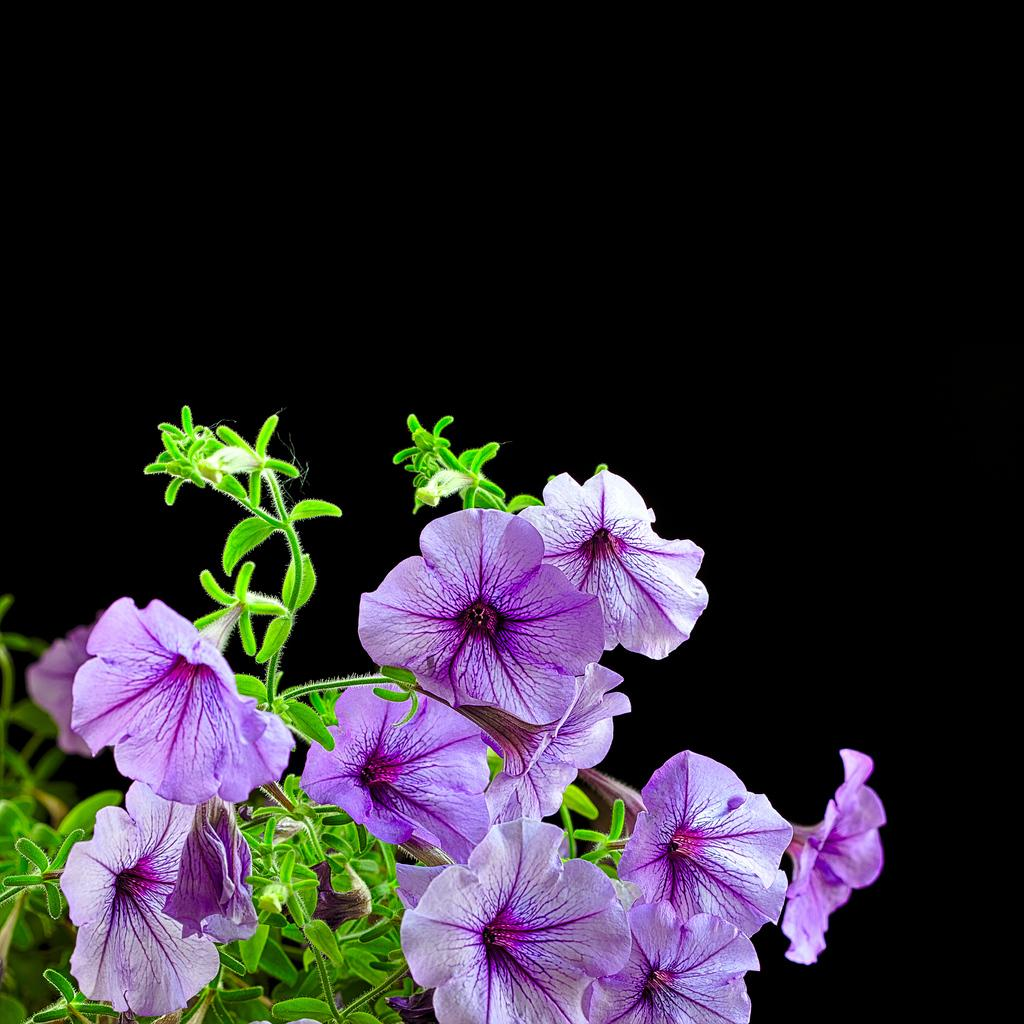What type of flowers can be seen on the left side of the image? There are flowers in brinjal color on the left side of the image. What color are the plants in the image? The plants in the image are green. Can you tell me how many celery stalks are present in the image? There is no celery present in the image. Is there a judge visible in the image? There is no judge present in the image. 